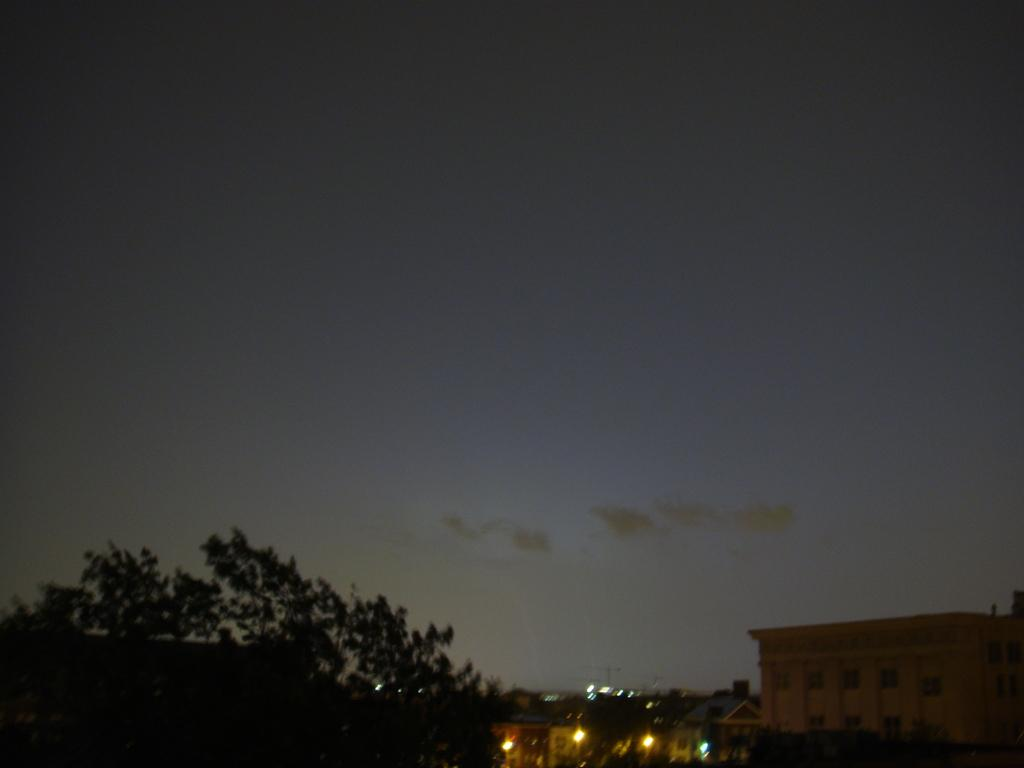What can be seen in the sky in the image? There are clouds in the sky in the image. What type of natural element is present in the image? There is a tree in the image. What type of structures are visible at the bottom of the image? There are buildings at the bottom of the image. What might be used for illumination in the image? There are lights visible in the image. Can you see any ants crawling on the tree in the image? There is no ant present in the image; it only features clouds, a tree, buildings, and lights. How many yaks are visible in the image? There are no yaks present in the image. 